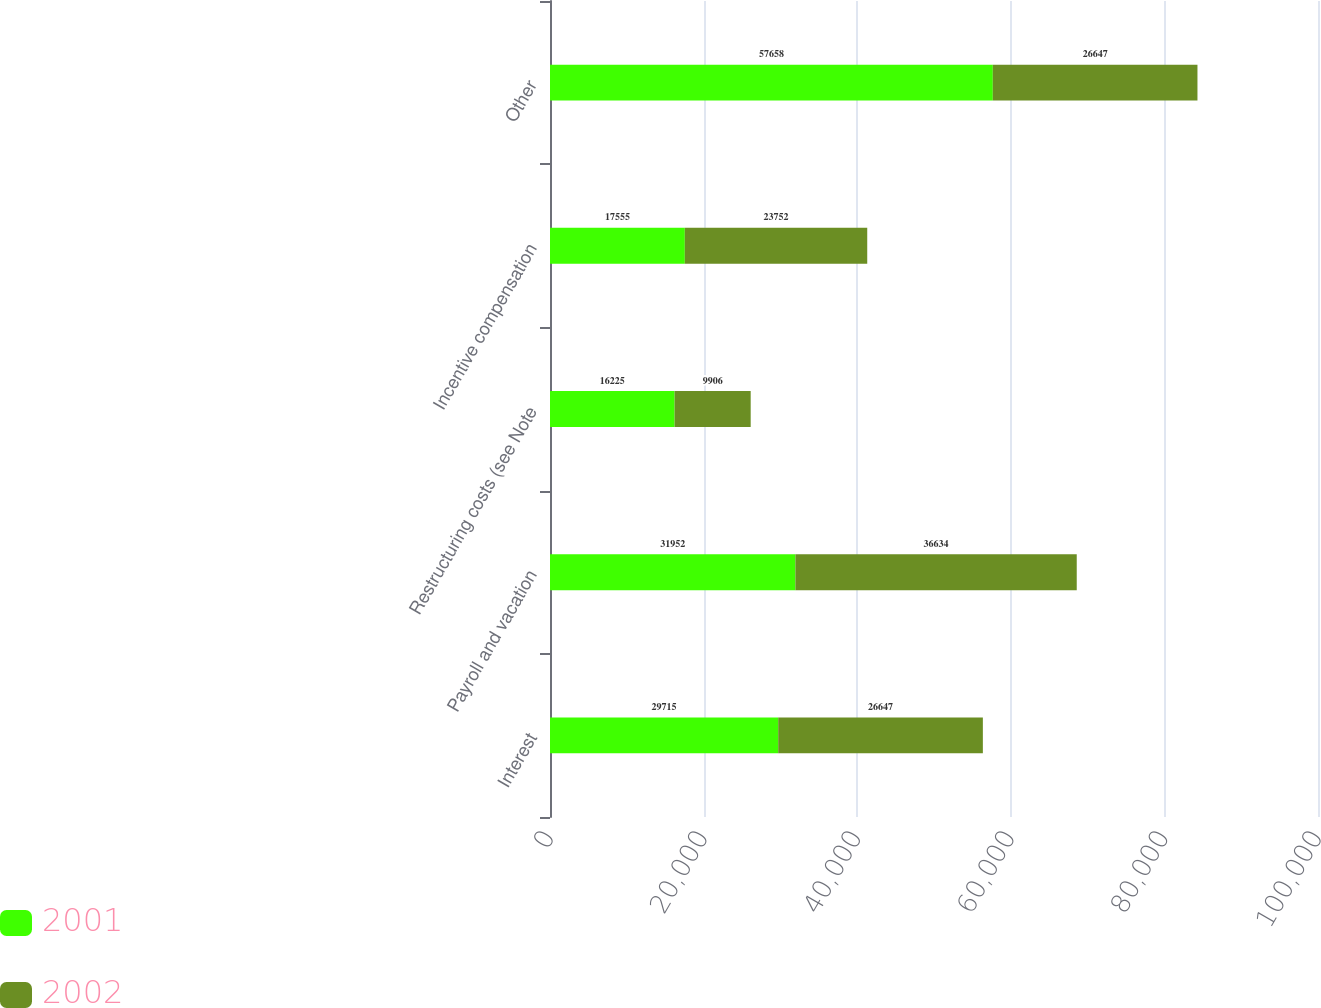Convert chart to OTSL. <chart><loc_0><loc_0><loc_500><loc_500><stacked_bar_chart><ecel><fcel>Interest<fcel>Payroll and vacation<fcel>Restructuring costs (see Note<fcel>Incentive compensation<fcel>Other<nl><fcel>2001<fcel>29715<fcel>31952<fcel>16225<fcel>17555<fcel>57658<nl><fcel>2002<fcel>26647<fcel>36634<fcel>9906<fcel>23752<fcel>26647<nl></chart> 